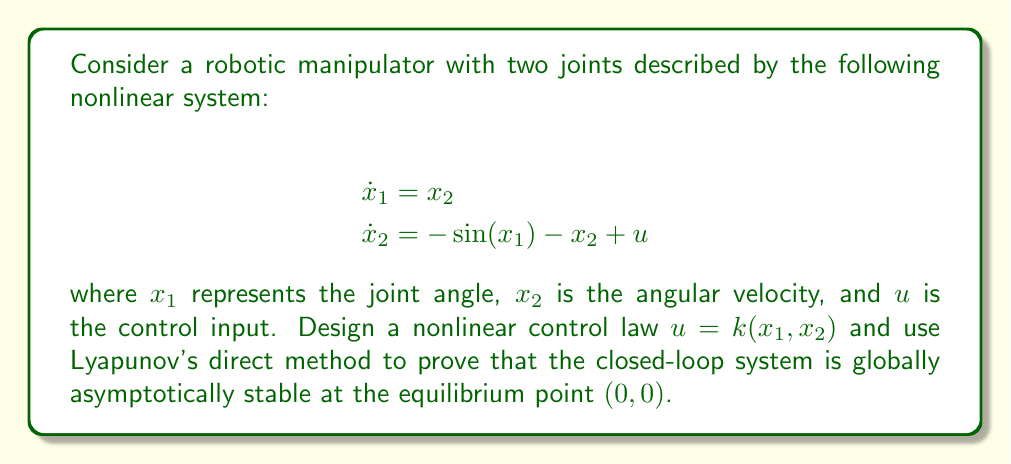Could you help me with this problem? To analyze the stability of this nonlinear control system using Lyapunov's direct method, we'll follow these steps:

1) First, we need to design a control law. Let's choose:

   $$u = \sin(x_1) + ax_1$$

   where $a > 0$ is a constant. This control law aims to cancel the nonlinearity and add a stabilizing term.

2) The closed-loop system becomes:

   $$\begin{align}
   \dot{x}_1 &= x_2 \\
   \dot{x}_2 &= -x_2 + ax_1
   \end{align}$$

3) Now, we need to propose a Lyapunov function candidate. Let's choose:

   $$V(x_1, x_2) = \frac{1}{2}x_1^2 + \frac{1}{2}x_2^2 + \frac{1}{2a}(x_2 - ax_1)^2$$

4) We need to verify that $V(x_1, x_2)$ is positive definite:
   - $V(0, 0) = 0$
   - For $(x_1, x_2) \neq (0, 0)$, $V(x_1, x_2) > 0$ since it's a sum of squared terms

5) Next, we calculate the time derivative of $V$ along the trajectories of the system:

   $$\begin{align}
   \dot{V} &= x_1\dot{x}_1 + x_2\dot{x}_2 + \frac{1}{a}(x_2 - ax_1)(\dot{x}_2 - a\dot{x}_1) \\
   &= x_1x_2 + x_2(-x_2 + ax_1) + \frac{1}{a}(x_2 - ax_1)(-x_2 + ax_1 - ax_2) \\
   &= x_1x_2 - x_2^2 + ax_1x_2 - \frac{1}{a}(x_2 - ax_1)x_2 \\
   &= -x_2^2
   \end{align}$$

6) We observe that $\dot{V}$ is negative semidefinite. To prove asymptotic stability, we need to use LaSalle's invariance principle:

   - The set where $\dot{V} = 0$ is $\{(x_1, x_2) | x_2 = 0\}$
   - In this set, the system dynamics reduce to $\dot{x}_1 = 0$ and $\dot{x}_2 = ax_1$
   - The only solution that can stay identically in this set is $x_1 = x_2 = 0$

7) Therefore, by LaSalle's invariance principle, the system is globally asymptotically stable at the equilibrium point $(0, 0)$.
Answer: The nonlinear control law $u = \sin(x_1) + ax_1$, where $a > 0$, globally asymptotically stabilizes the system at the equilibrium point $(0, 0)$. This is proven using the Lyapunov function $V(x_1, x_2) = \frac{1}{2}x_1^2 + \frac{1}{2}x_2^2 + \frac{1}{2a}(x_2 - ax_1)^2$ and LaSalle's invariance principle. 